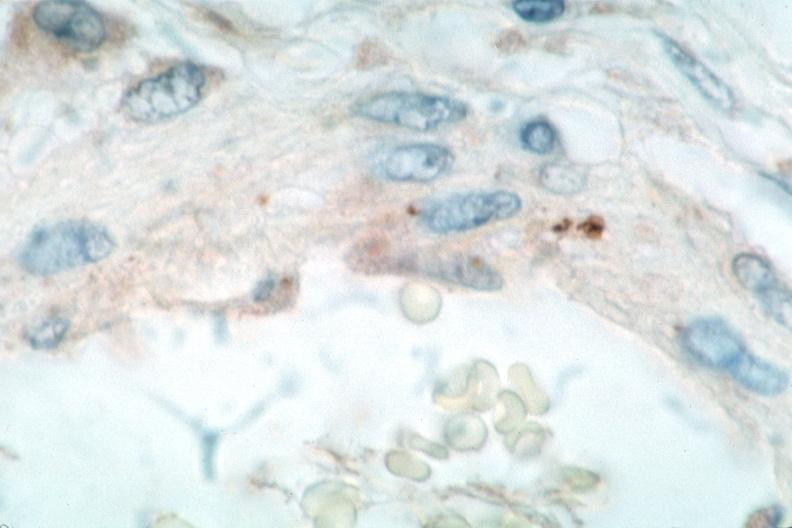what is rocky mountain spotted?
Answer the question using a single word or phrase. Fever 